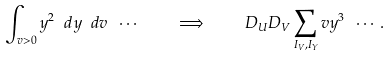<formula> <loc_0><loc_0><loc_500><loc_500>\int _ { v > 0 } y ^ { 2 } \ d y \ d v \ \cdots \quad \Longrightarrow \quad D _ { U } D _ { V } \sum _ { I _ { V } , I _ { Y } } v y ^ { 3 } \ \cdots .</formula> 